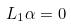Convert formula to latex. <formula><loc_0><loc_0><loc_500><loc_500>L _ { 1 } \alpha = 0</formula> 